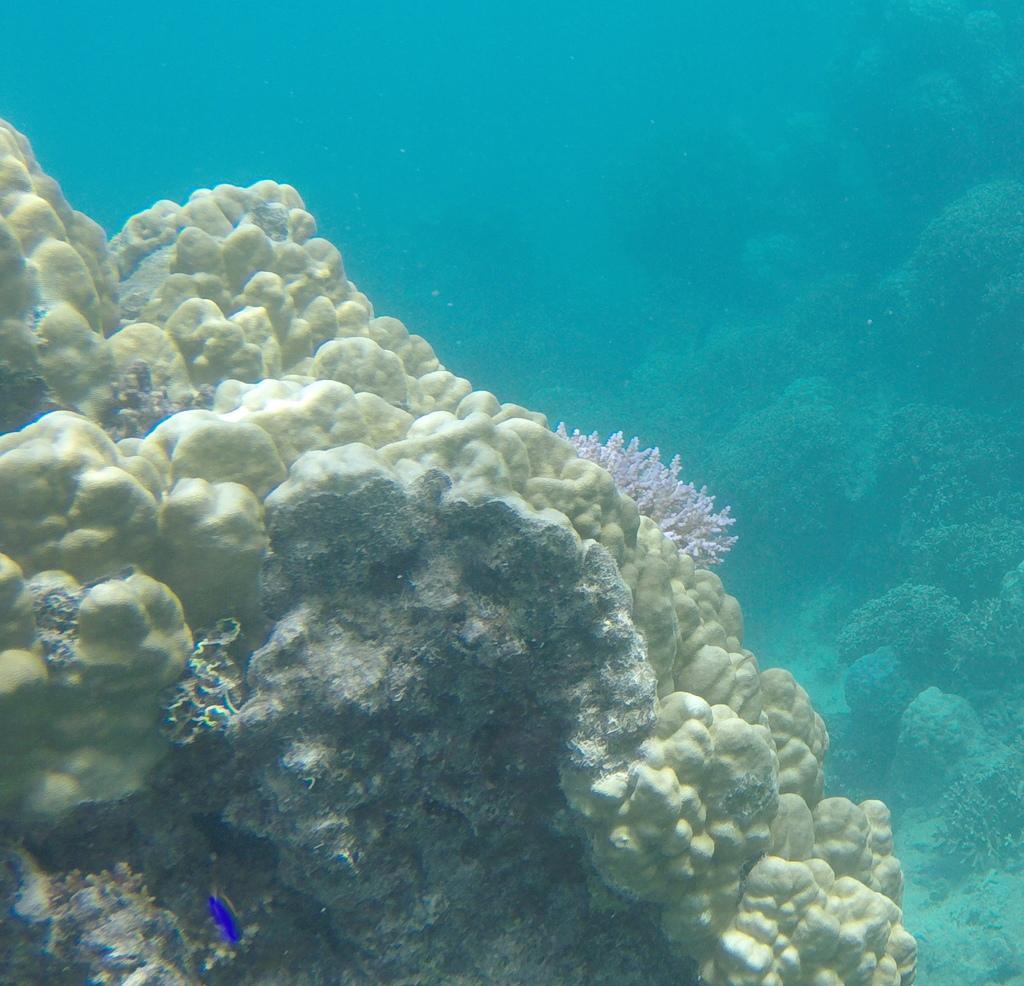What type of underwater environment is depicted in the image? The image features reefs. Are there any animals visible in the image? Yes, there is a fish in the water in the image. How many legs can be seen on the fish in the image? Fish do not have legs, so there are no legs visible on the fish in the image. 